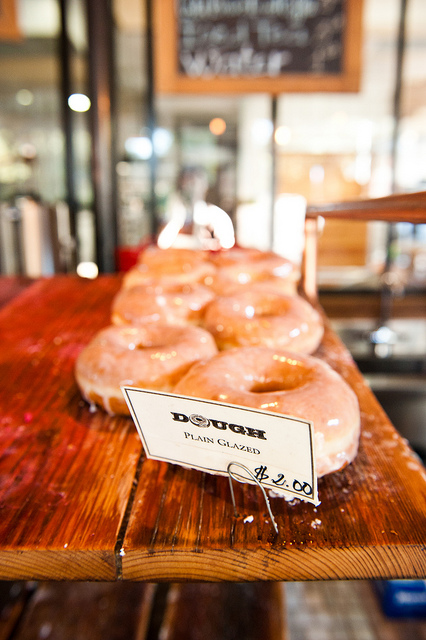Please extract the text content from this image. DOUGH PLAIN GLAZED 2 00 